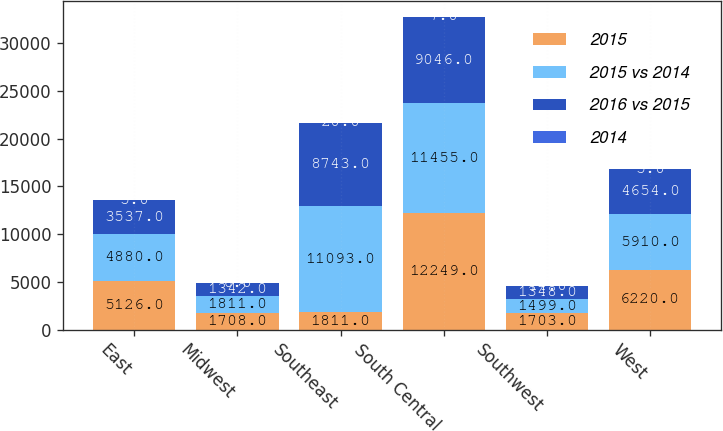Convert chart. <chart><loc_0><loc_0><loc_500><loc_500><stacked_bar_chart><ecel><fcel>East<fcel>Midwest<fcel>Southeast<fcel>South Central<fcel>Southwest<fcel>West<nl><fcel>2015<fcel>5126<fcel>1708<fcel>1811<fcel>12249<fcel>1703<fcel>6220<nl><fcel>2015 vs 2014<fcel>4880<fcel>1811<fcel>11093<fcel>11455<fcel>1499<fcel>5910<nl><fcel>2016 vs 2015<fcel>3537<fcel>1342<fcel>8743<fcel>9046<fcel>1348<fcel>4654<nl><fcel>2014<fcel>5<fcel>6<fcel>20<fcel>7<fcel>14<fcel>5<nl></chart> 